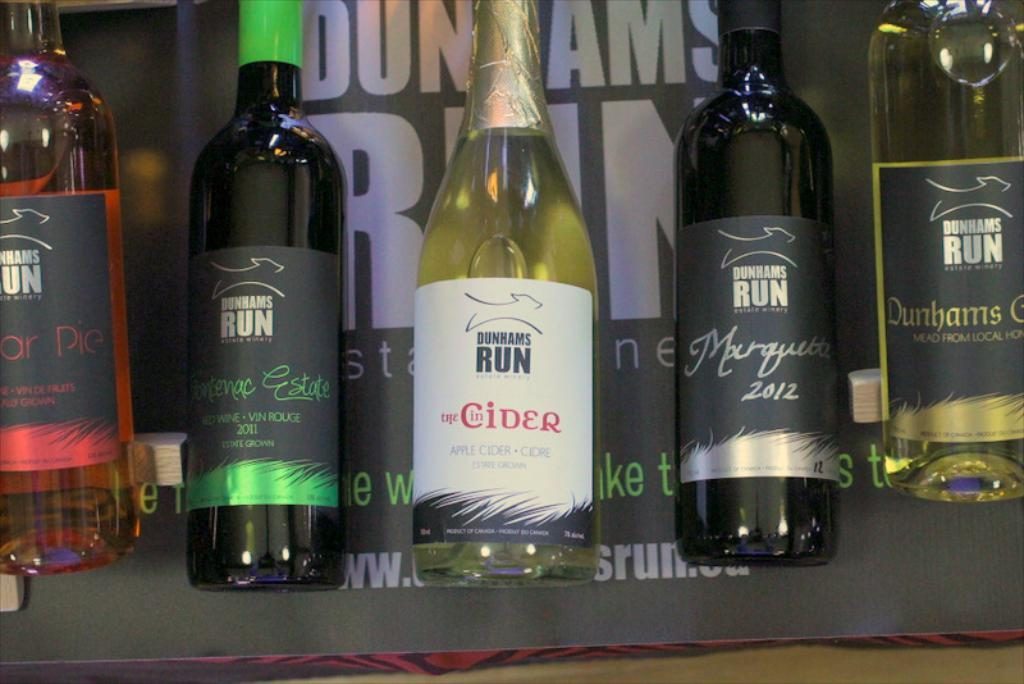How many bottles are visible in the image? There are five bottles in the image. What else can be seen in the background of the image? There is a board in the background of the image. What type of behavior can be observed in the sleet during the voyage in the image? There is no sleet or voyage present in the image; it only features five bottles and a board in the background. 